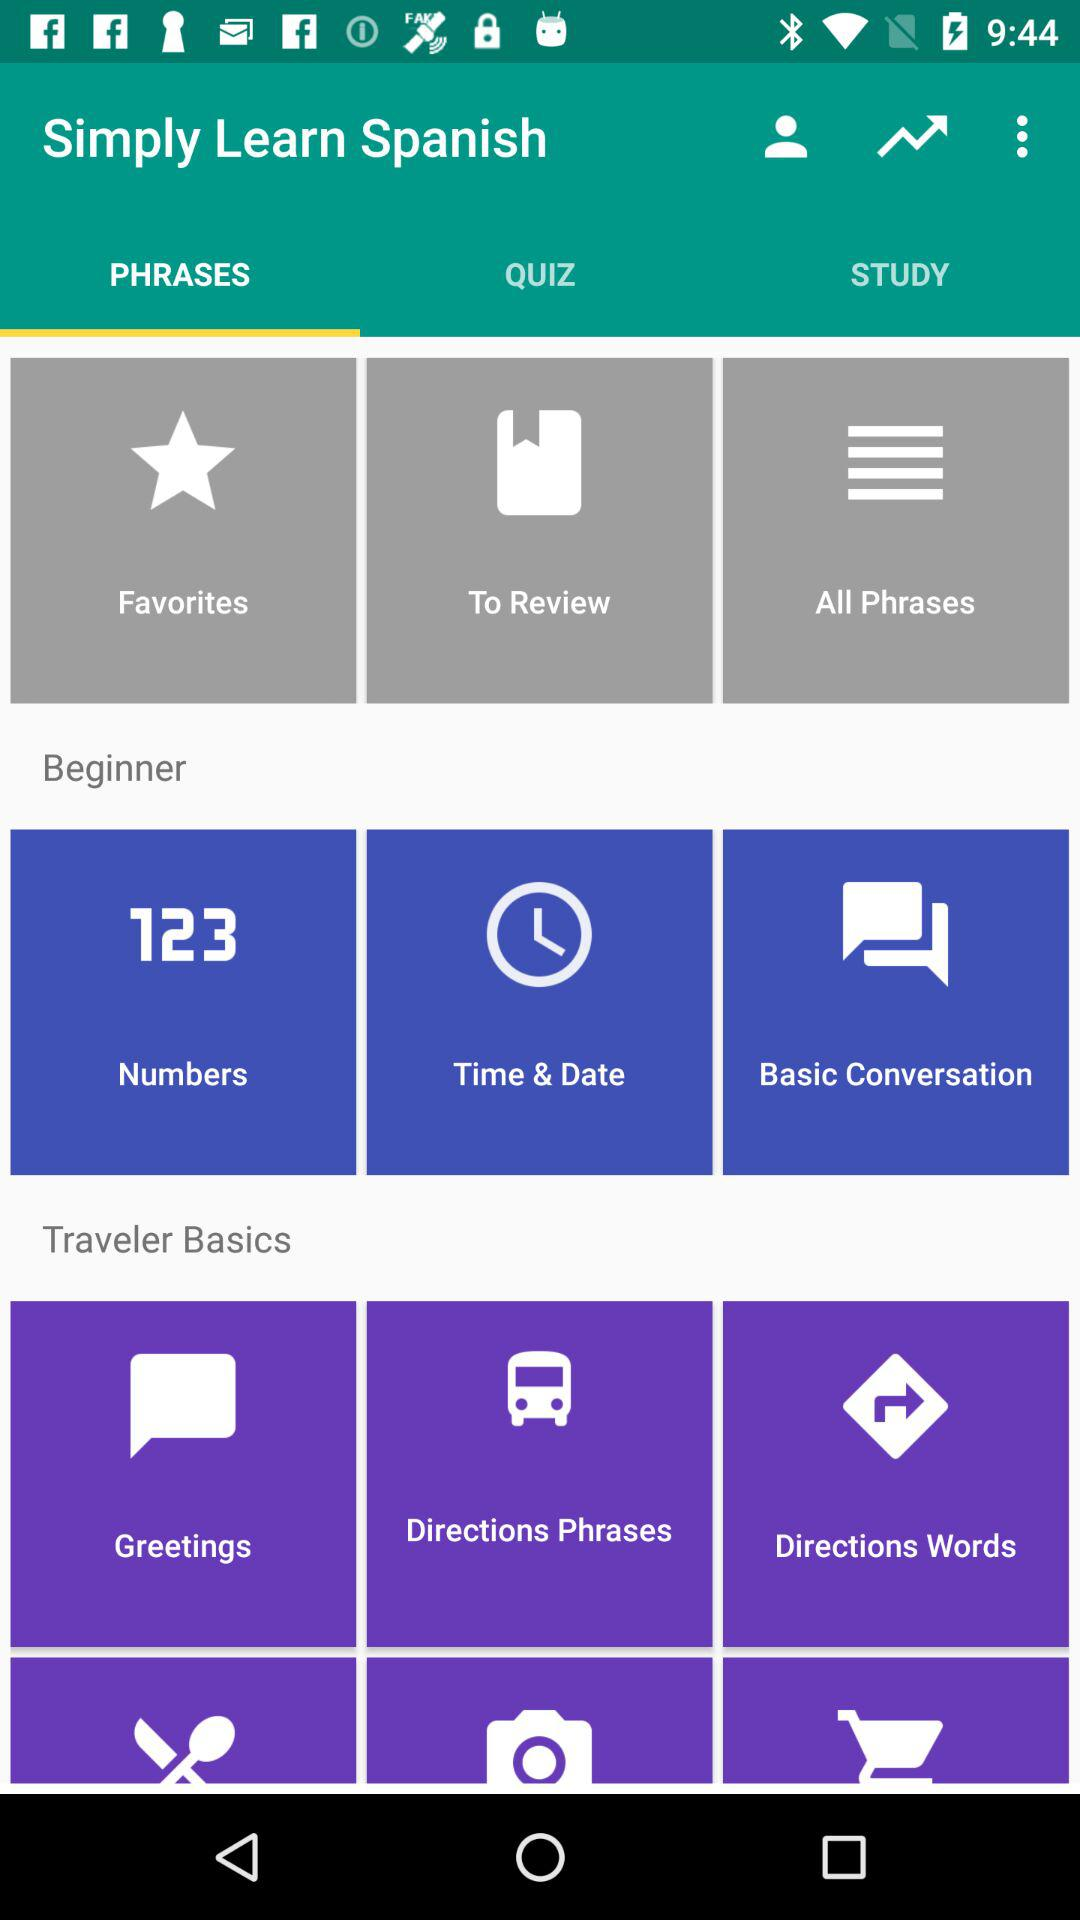How many members are there?
When the provided information is insufficient, respond with <no answer>. <no answer> 